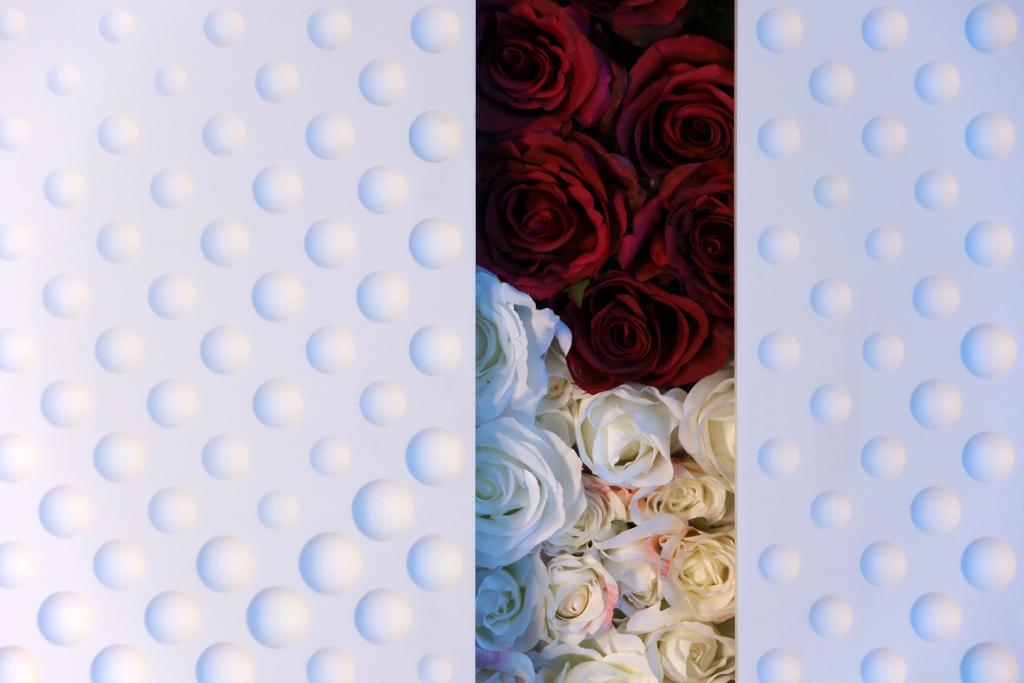In one or two sentences, can you explain what this image depicts? In this picture I can see the flowers. 